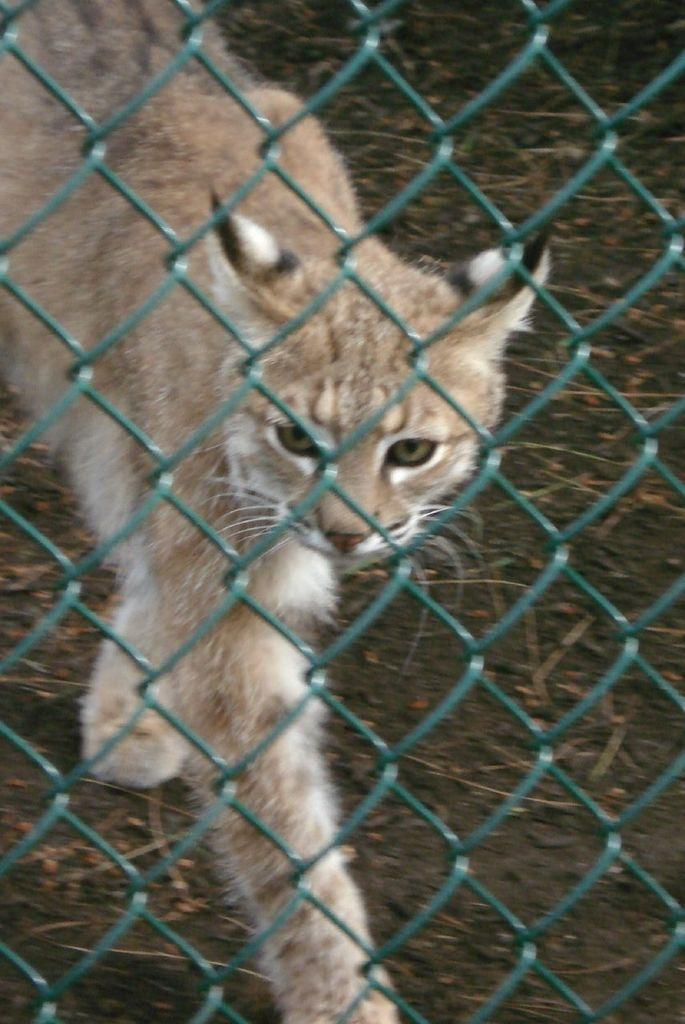What is the main subject in the center of the image? There is there a cat in the center of the image? What is in front of the cat? There is a net in front of the cat. What type of tent can be seen in the cat's grandmother using in the image? There is no tent or grandmother present in the image; it only features a cat and a net. How does the brake system work on the cat in the image? There is no brake system on the cat in the image, as cats do not have brake systems. 